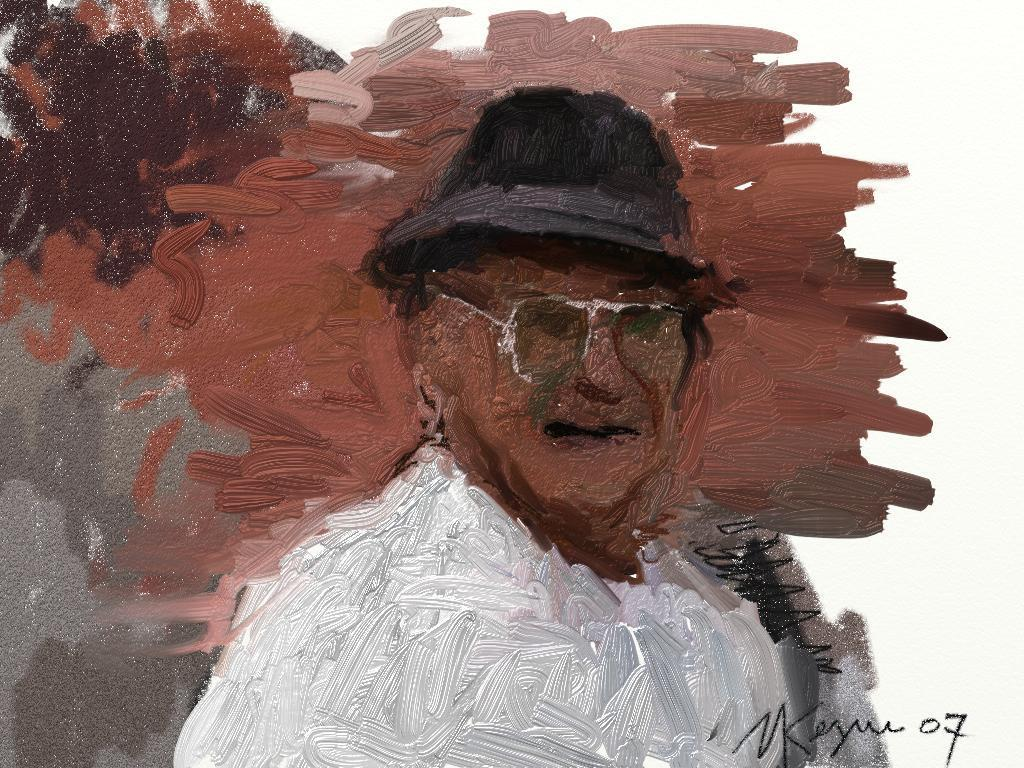What is the main subject of the painting in the image? There is a painting of a person in the image. Where is the text located on the painting? The text is written on the right bottom side of the painting. What colors are used in the painting? The painting's color scheme includes brown, black, grey, and white. What date is circled on the calendar in the image? There is no calendar present in the image; it only features a painting with text and a specific color scheme. What type of sound can be heard coming from the fork in the image? There is no fork present in the image, so it is not possible to determine what sound might be associated with it. 